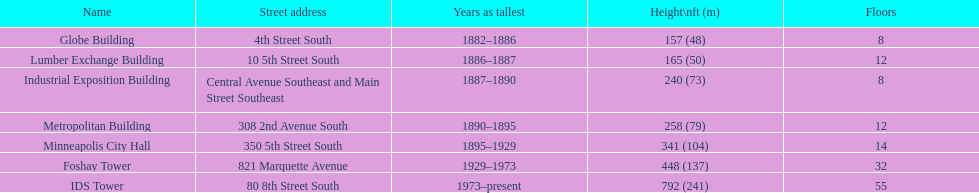Between the metropolitan building and the lumber exchange building, which one has a greater height? Metropolitan Building. 